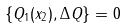<formula> <loc_0><loc_0><loc_500><loc_500>\left \{ Q _ { 1 } ( x _ { 2 } ) , \Delta Q \right \} = 0</formula> 